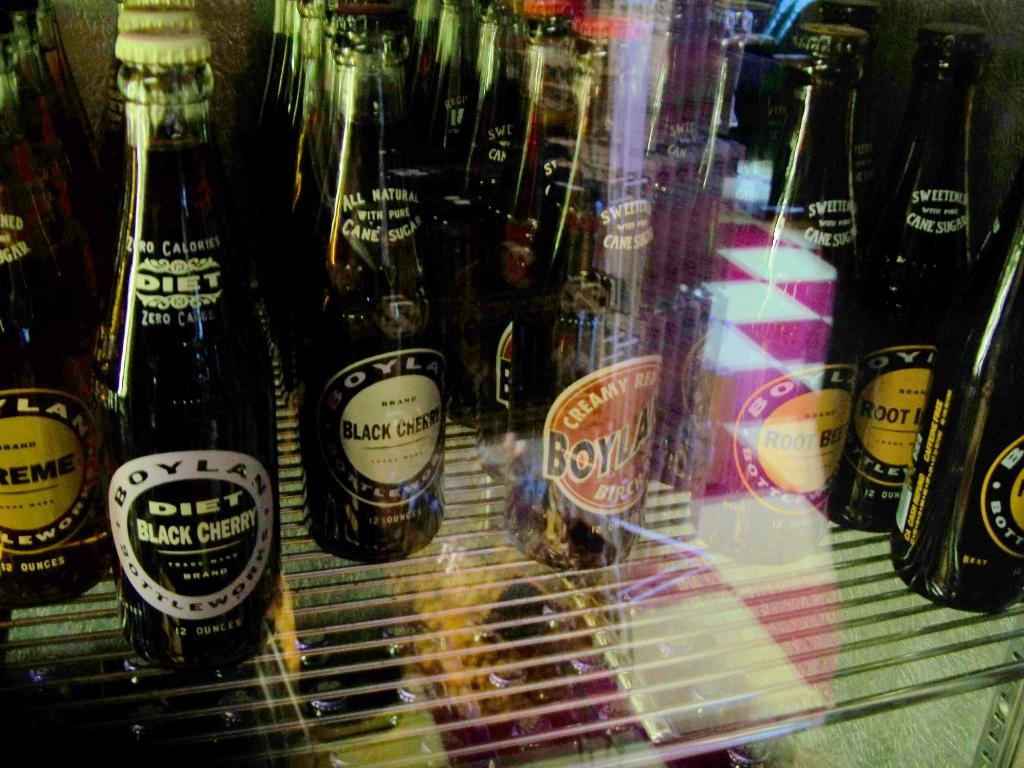<image>
Provide a brief description of the given image. Bottles of Diet Black Cherry alcohol sitting on a store shelf. 